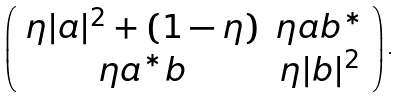Convert formula to latex. <formula><loc_0><loc_0><loc_500><loc_500>\left ( \begin{array} { c c } \eta | a | ^ { 2 } + ( 1 - \eta ) & \eta a b ^ { * } \\ \eta a ^ { * } b & \eta | b | ^ { 2 } \end{array} \right ) .</formula> 